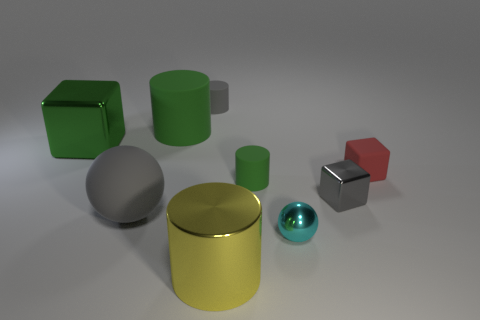There is a tiny gray thing that is behind the small red object; is it the same shape as the large object in front of the large sphere?
Your response must be concise. Yes. How many metal blocks have the same color as the large matte ball?
Provide a succinct answer. 1. Is the shape of the green rubber object to the left of the large metallic cylinder the same as  the yellow metal object?
Provide a short and direct response. Yes. Is the yellow shiny thing the same shape as the large green rubber thing?
Ensure brevity in your answer.  Yes. What shape is the metallic object behind the tiny matte thing in front of the tiny red cube?
Keep it short and to the point. Cube. The big thing to the left of the big gray matte thing is what color?
Ensure brevity in your answer.  Green. The gray sphere that is made of the same material as the red cube is what size?
Ensure brevity in your answer.  Large. What size is the gray object that is the same shape as the small green matte object?
Offer a terse response. Small. Is there a tiny green cylinder?
Offer a terse response. Yes. How many things are small matte things to the right of the gray shiny object or tiny spheres?
Your answer should be compact. 2. 